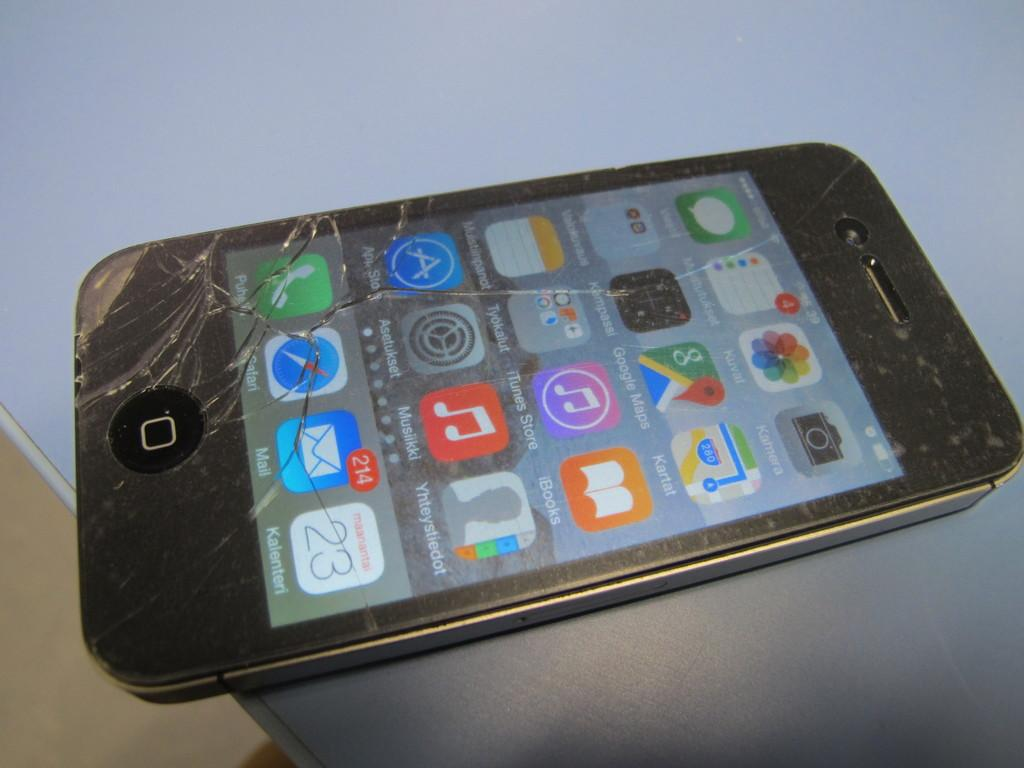<image>
Create a compact narrative representing the image presented. a touchscreen phone with a shattered front and various options such as Google maps sits on a small table 